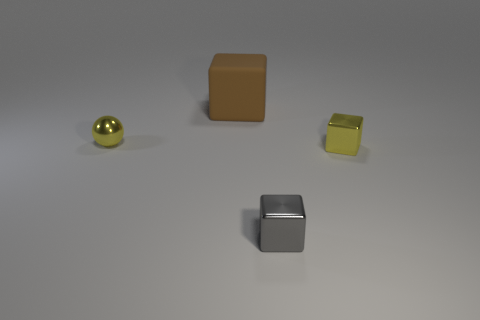Subtract all big blocks. How many blocks are left? 2 Add 3 small yellow things. How many objects exist? 7 Subtract all yellow shiny cubes. Subtract all brown metallic cylinders. How many objects are left? 3 Add 4 cubes. How many cubes are left? 7 Add 1 large gray metallic things. How many large gray metallic things exist? 1 Subtract 0 red cylinders. How many objects are left? 4 Subtract all blocks. How many objects are left? 1 Subtract all cyan cubes. Subtract all blue spheres. How many cubes are left? 3 Subtract all red spheres. How many gray blocks are left? 1 